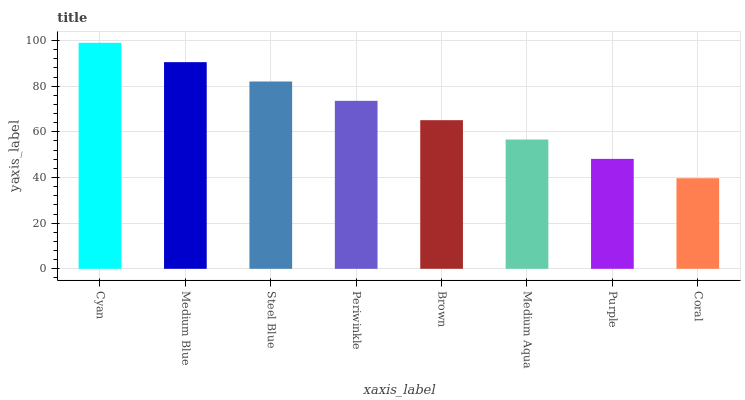Is Coral the minimum?
Answer yes or no. Yes. Is Cyan the maximum?
Answer yes or no. Yes. Is Medium Blue the minimum?
Answer yes or no. No. Is Medium Blue the maximum?
Answer yes or no. No. Is Cyan greater than Medium Blue?
Answer yes or no. Yes. Is Medium Blue less than Cyan?
Answer yes or no. Yes. Is Medium Blue greater than Cyan?
Answer yes or no. No. Is Cyan less than Medium Blue?
Answer yes or no. No. Is Periwinkle the high median?
Answer yes or no. Yes. Is Brown the low median?
Answer yes or no. Yes. Is Steel Blue the high median?
Answer yes or no. No. Is Medium Aqua the low median?
Answer yes or no. No. 